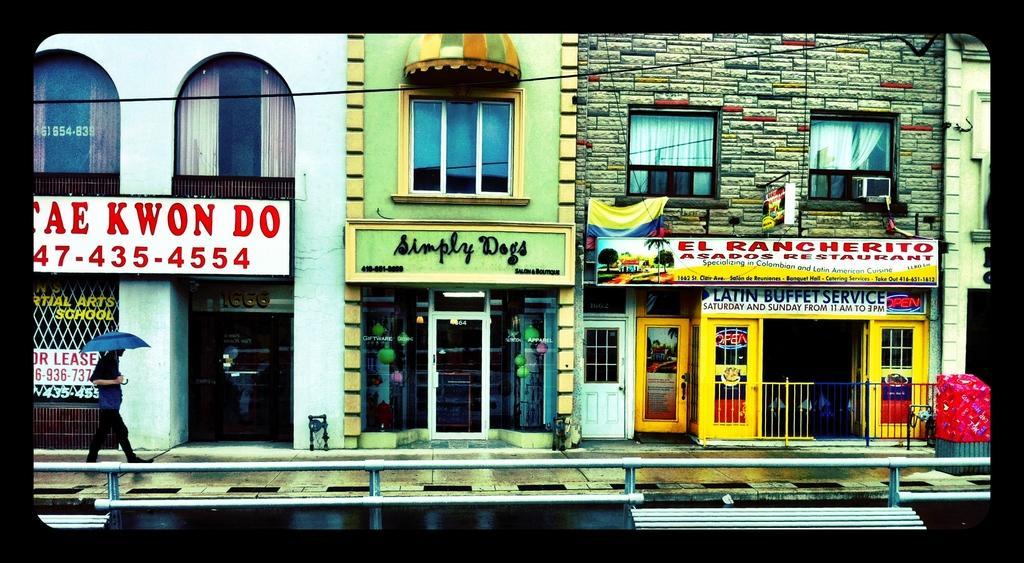How would you summarize this image in a sentence or two? In this image in the center there are some buildings and stores and there is one person who is holding umbrella and walking on a footpath. At the bottom there is railing and also we could see some boards, on the boards there is some text. 